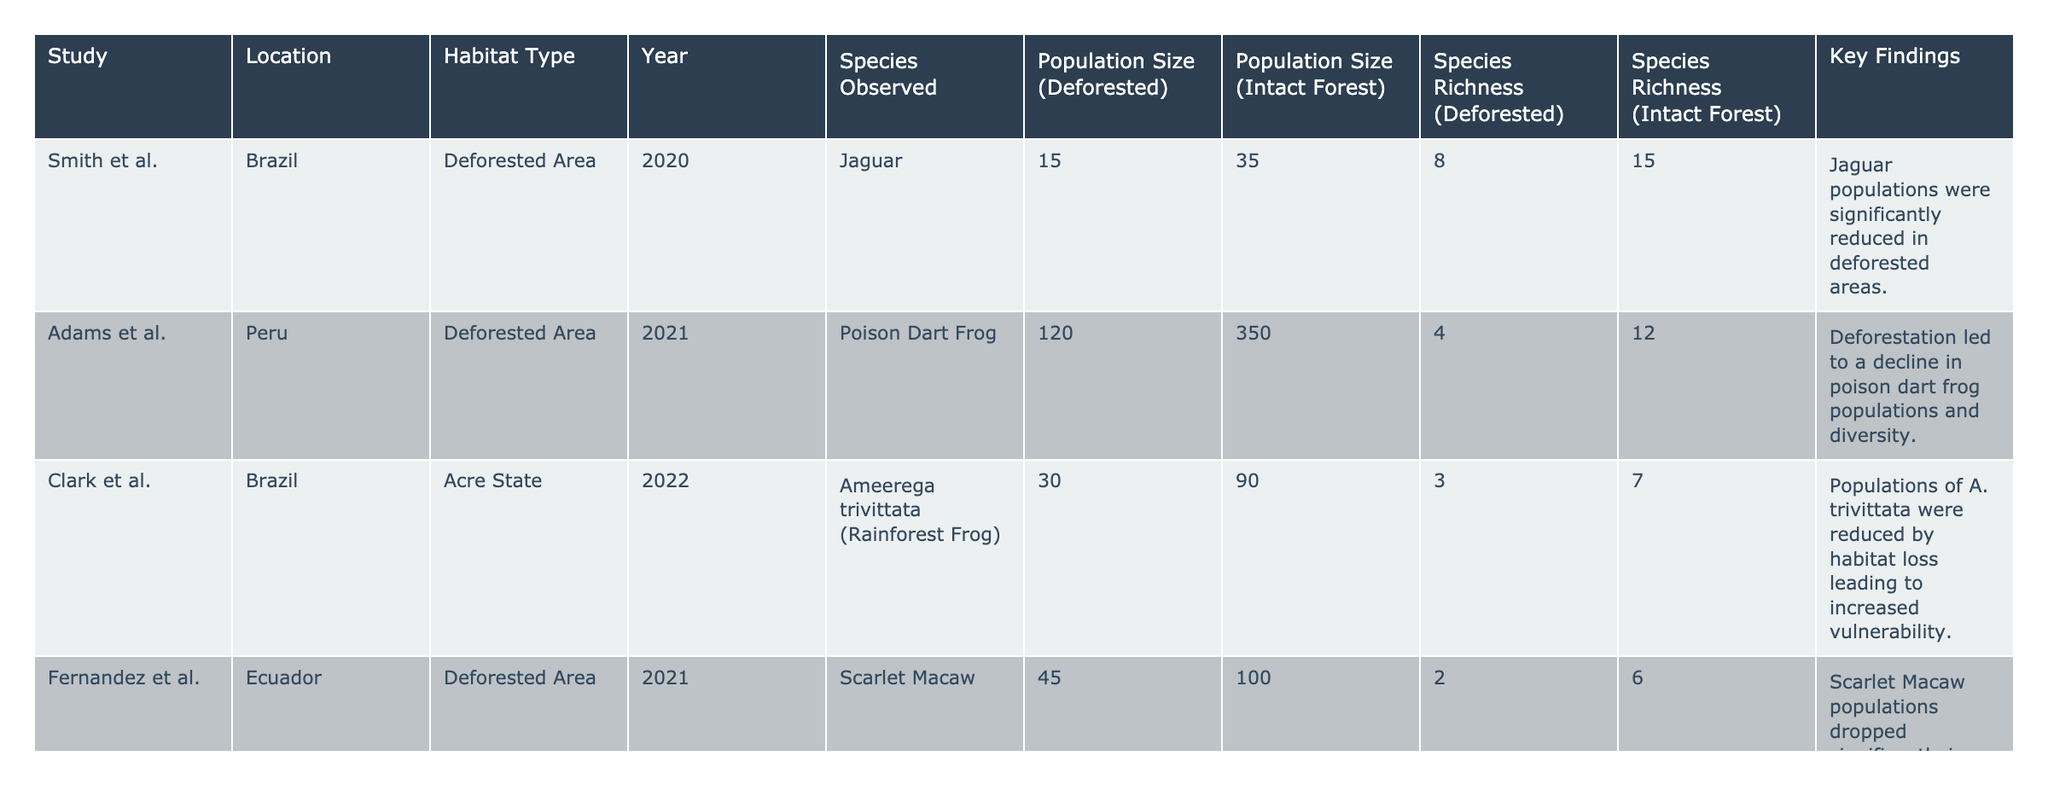What is the population size of Jaguars in deforested areas? The table indicates that the population size of Jaguars in deforested areas, as reported by Smith et al., is 15.
Answer: 15 What is the species richness for Poison Dart Frogs in intact forest areas? According to Adams et al., the species richness for Poison Dart Frogs in intact forest areas is 12.
Answer: 12 Which study indicates that Deforestation has nearly halved sloth populations? Robinson & Wang's study states that deforestation has nearly halved sloth populations, which is reflected in the population sizes listed in deforested versus intact areas.
Answer: Robinson & Wang What is the total population size difference for Black Caimans between deforested and intact forest areas? The population size of Black Caimans in deforested areas is 60, and in intact forest areas, it is 180. The difference is calculated as 180 - 60 = 120.
Answer: 120 What is the average species richness in deforested areas based on the studies provided? The species richness values for deforested areas are 8 (Jaguar), 4 (Poison Dart Frog), 3 (A. trivittata), 2 (Scarlet Macaw), 3 (Blue Poison Dart Frog), and 6 (Black Caiman), amounting to 26. There are 6 species observed, making the average 26 / 6 ≈ 4.33.
Answer: 4.33 Is the population size of Six-Tik Wings in deforested areas more than the average population of species in intact forests? The population of Six-Tik Wings in intact forests is 450. To check against deforested areas, we sum the population sizes of all species in intact forests (35 + 350 + 90 + 100 + 150 + 450 = 1175) and divide by 6 (the number of species), resulting in an average of 195. Therefore, 450 > 195.
Answer: Yes Which species had the highest population size in intact forest areas? The population size for Six-Tik Wing in intact forest areas is the highest at 450 according to Miller & Santos.
Answer: 450 Did all species studied show a decline in population size from deforested to intact forest areas? By examining the population sizes, it is evident that not all species show a decline; specifically, the population of Tapirs in intact forests (150) is greater than in deforested (75), indicating no overall decline for this species.
Answer: No 